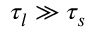<formula> <loc_0><loc_0><loc_500><loc_500>\tau _ { l } \gg \tau _ { s }</formula> 